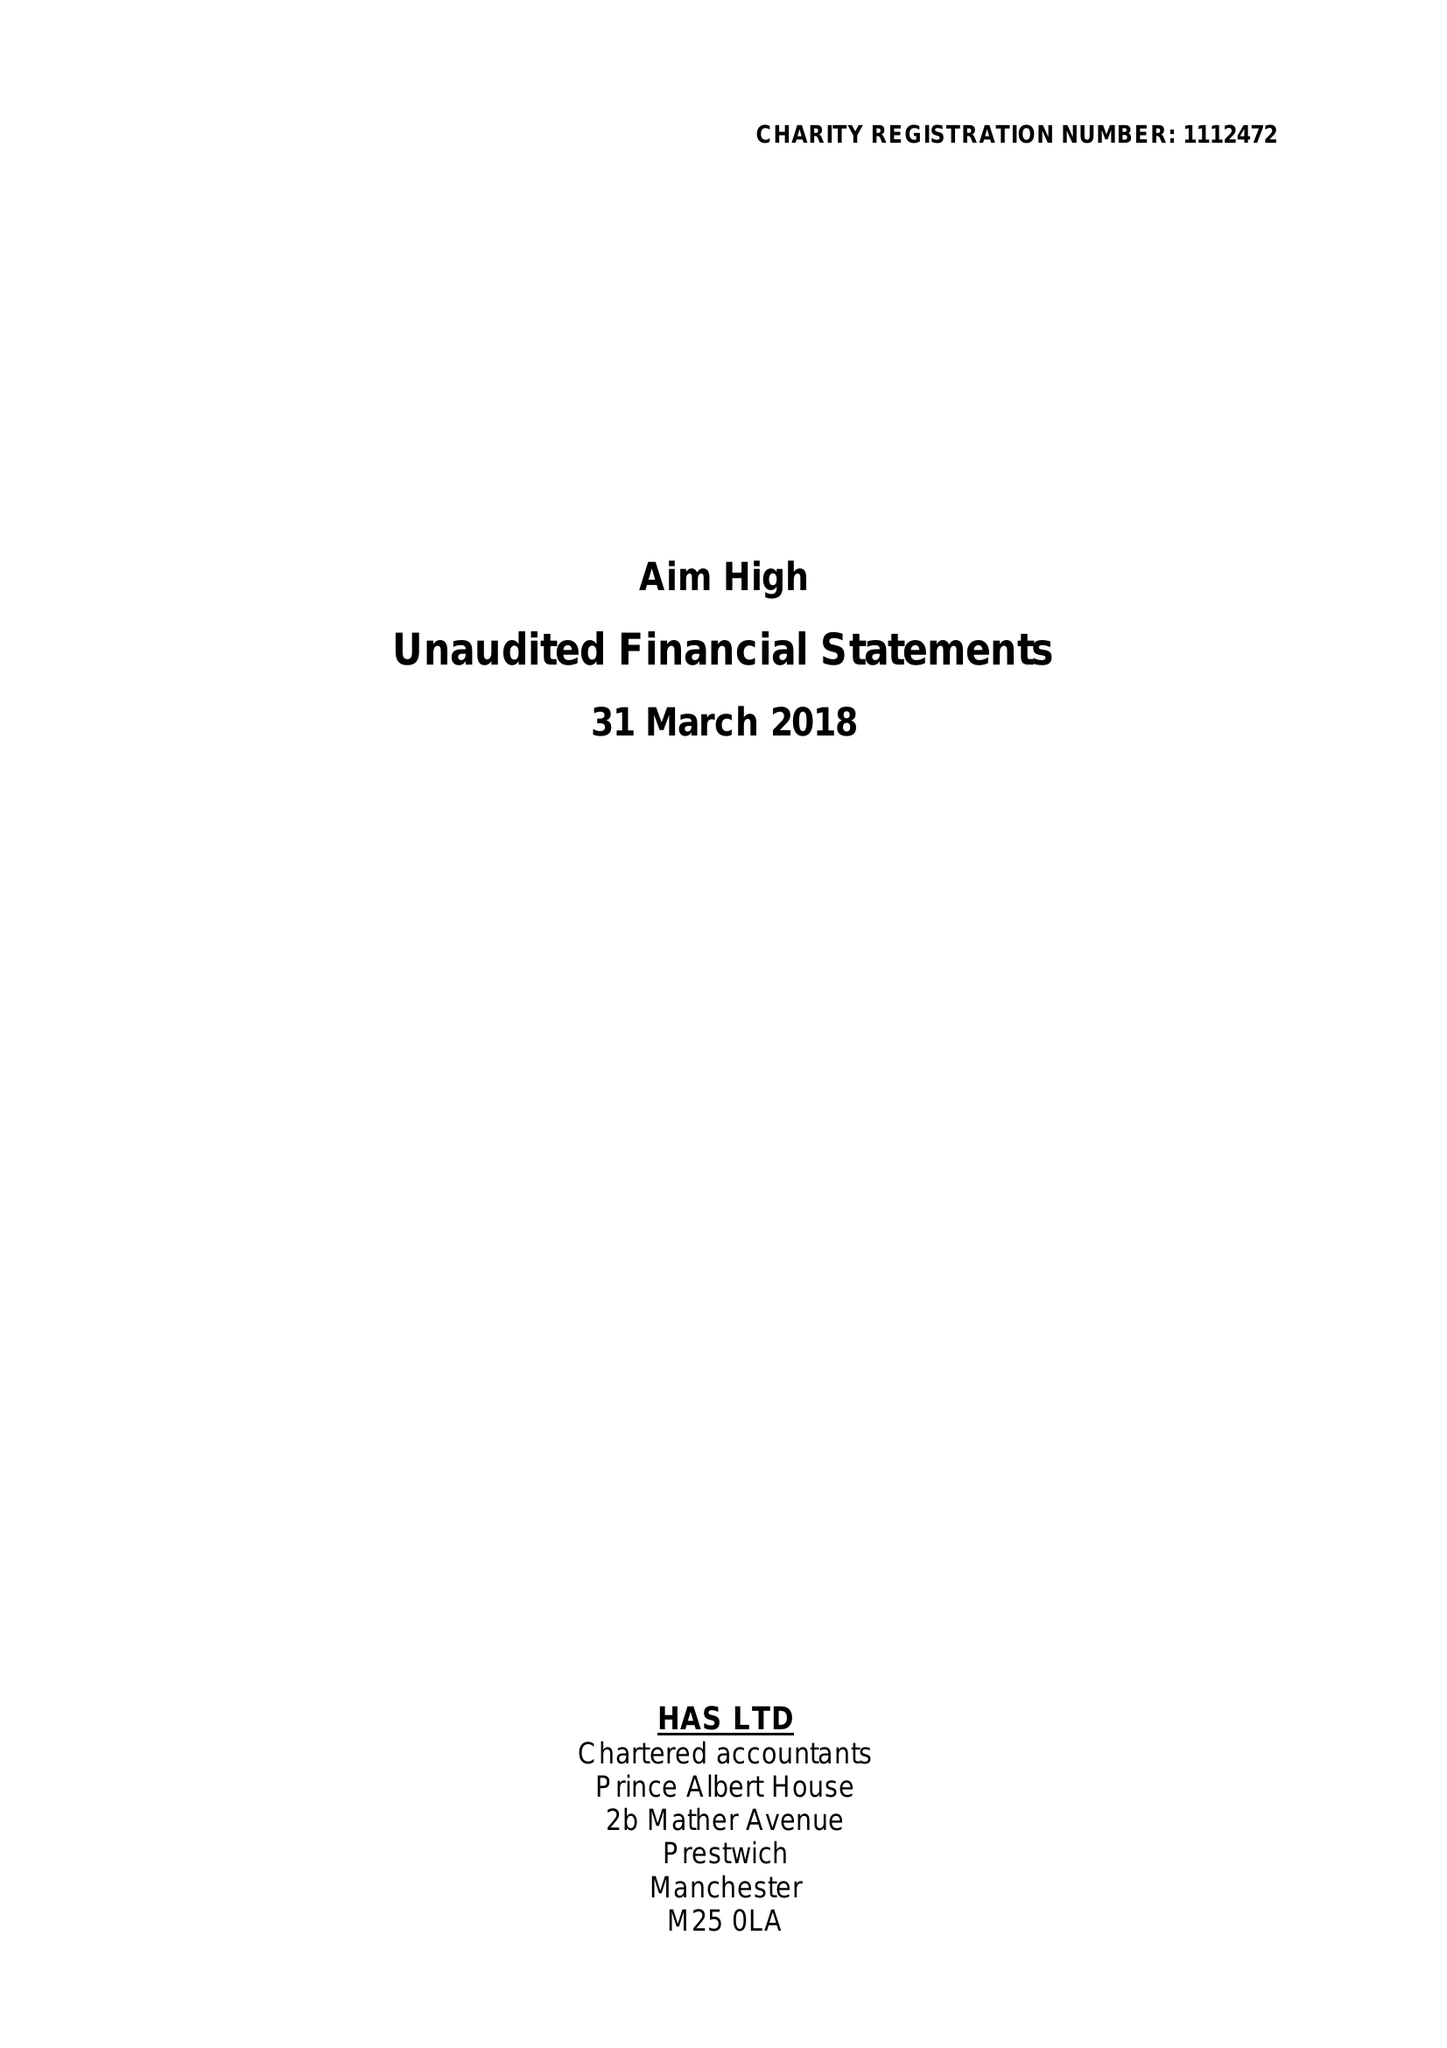What is the value for the charity_name?
Answer the question using a single word or phrase. Aim High 